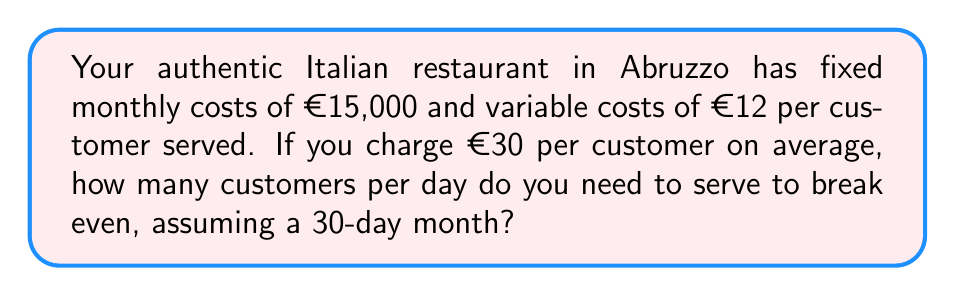Provide a solution to this math problem. Let's approach this step-by-step:

1) First, let's define our variables:
   $x$ = number of customers per day
   $30$ = number of days in a month

2) The total monthly revenue is:
   $R = 30 \cdot 30x = 900x$

3) The total monthly cost is:
   $C = 15000 + 30 \cdot 12x = 15000 + 360x$

4) To break even, revenue must equal cost:
   $R = C$
   $900x = 15000 + 360x$

5) Solve the equation:
   $900x - 360x = 15000$
   $540x = 15000$
   $x = \frac{15000}{540} = 27.78$

6) Since we can't serve a fraction of a customer, we need to round up to the nearest whole number:
   $x \geq 28$

Therefore, you need to serve at least 28 customers per day to break even.

7) We can express this as an inequality:
   $30 \cdot 30x - (15000 + 30 \cdot 12x) \geq 0$
   $900x - 15000 - 360x \geq 0$
   $540x - 15000 \geq 0$
   $540x \geq 15000$
   $x \geq \frac{15000}{540} \approx 27.78$

This confirms our earlier calculation.
Answer: $x \geq 28$ customers per day 